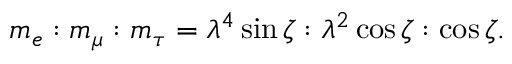Convert formula to latex. <formula><loc_0><loc_0><loc_500><loc_500>m _ { e } \colon m _ { \mu } \colon m _ { \tau } = \lambda ^ { 4 } \sin \zeta \colon \lambda ^ { 2 } \cos \zeta \colon \cos \zeta .</formula> 